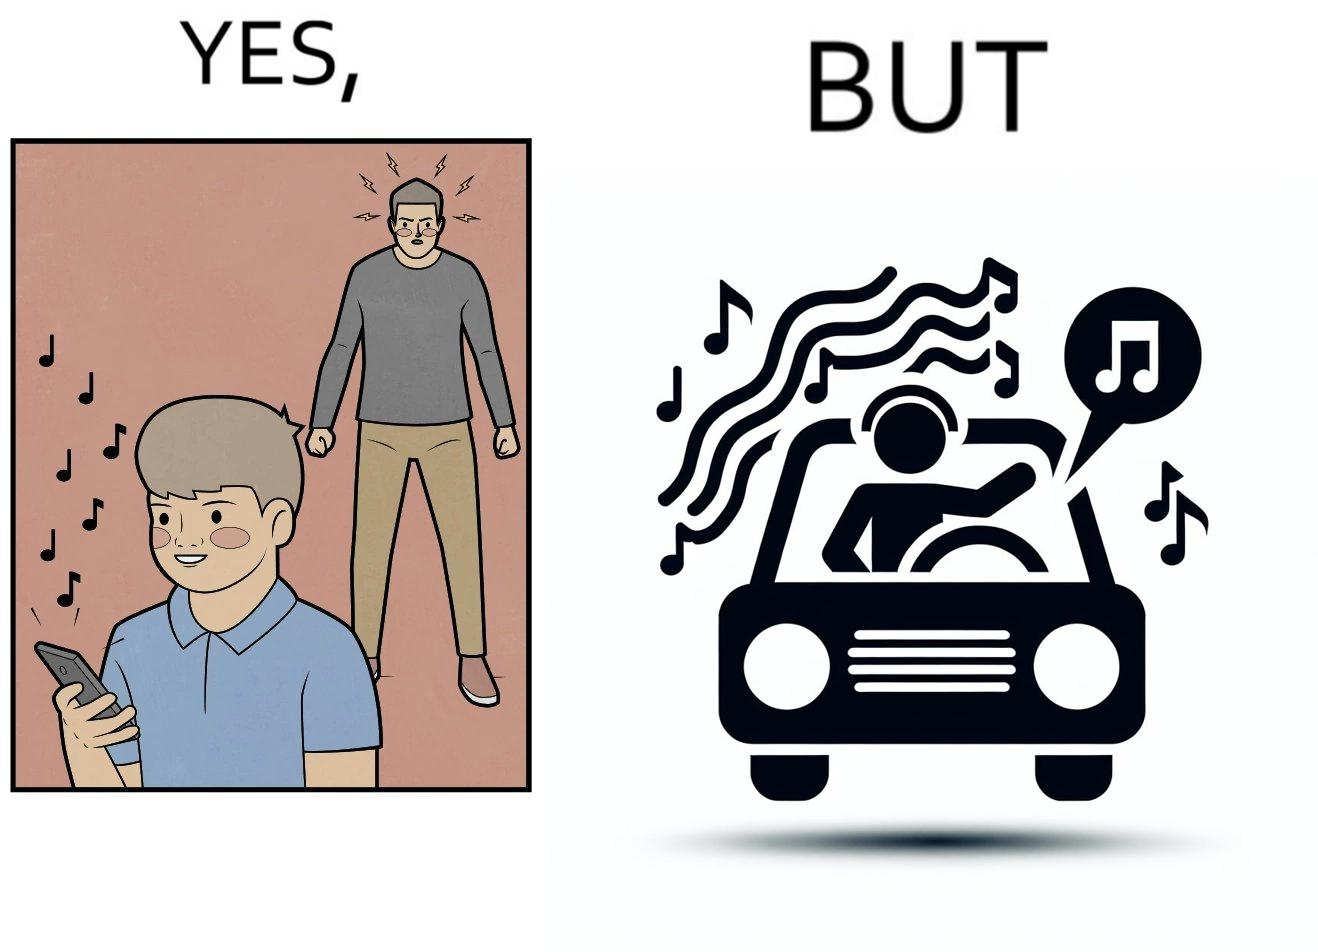Describe what you see in this image. The image is funny because while the man does not like the boy playing music loudly on his phone, the man himself is okay with doing the same thing with his car and playing loud music in the car with the sound coming out of the car. 